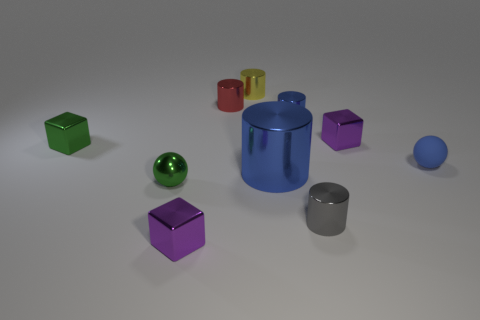Are there fewer small rubber balls than small purple metallic blocks? Upon reviewing the image, there are two small purple metallic blocks and only one small rubber ball visible, suggesting that there are indeed fewer small rubber balls than small purple metallic blocks. 